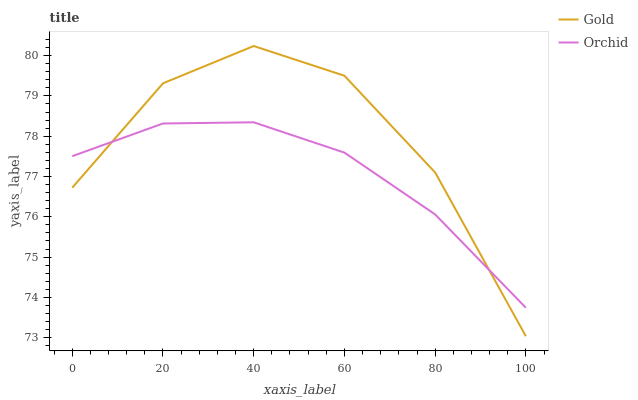Does Orchid have the minimum area under the curve?
Answer yes or no. Yes. Does Gold have the maximum area under the curve?
Answer yes or no. Yes. Does Orchid have the maximum area under the curve?
Answer yes or no. No. Is Orchid the smoothest?
Answer yes or no. Yes. Is Gold the roughest?
Answer yes or no. Yes. Is Orchid the roughest?
Answer yes or no. No. Does Orchid have the lowest value?
Answer yes or no. No. Does Orchid have the highest value?
Answer yes or no. No. 